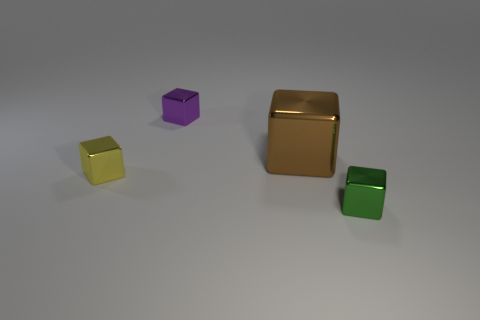Do the block to the left of the purple object and the metallic block in front of the tiny yellow thing have the same size?
Your response must be concise. Yes. The block that is both left of the brown cube and in front of the purple object is made of what material?
Your answer should be compact. Metal. Are there fewer green cubes than small yellow metal spheres?
Give a very brief answer. No. There is a metal object on the left side of the small purple cube behind the tiny yellow cube; what size is it?
Give a very brief answer. Small. What shape is the tiny metal thing left of the small shiny object that is behind the brown metal object that is to the right of the purple block?
Make the answer very short. Cube. What color is the other large cube that is the same material as the yellow cube?
Offer a terse response. Brown. What is the color of the block in front of the shiny thing on the left side of the small cube behind the yellow thing?
Ensure brevity in your answer.  Green. What number of spheres are brown objects or tiny objects?
Your response must be concise. 0. There is a large object; is it the same color as the tiny shiny thing that is on the right side of the large brown cube?
Your answer should be very brief. No. What is the color of the big shiny cube?
Make the answer very short. Brown. 